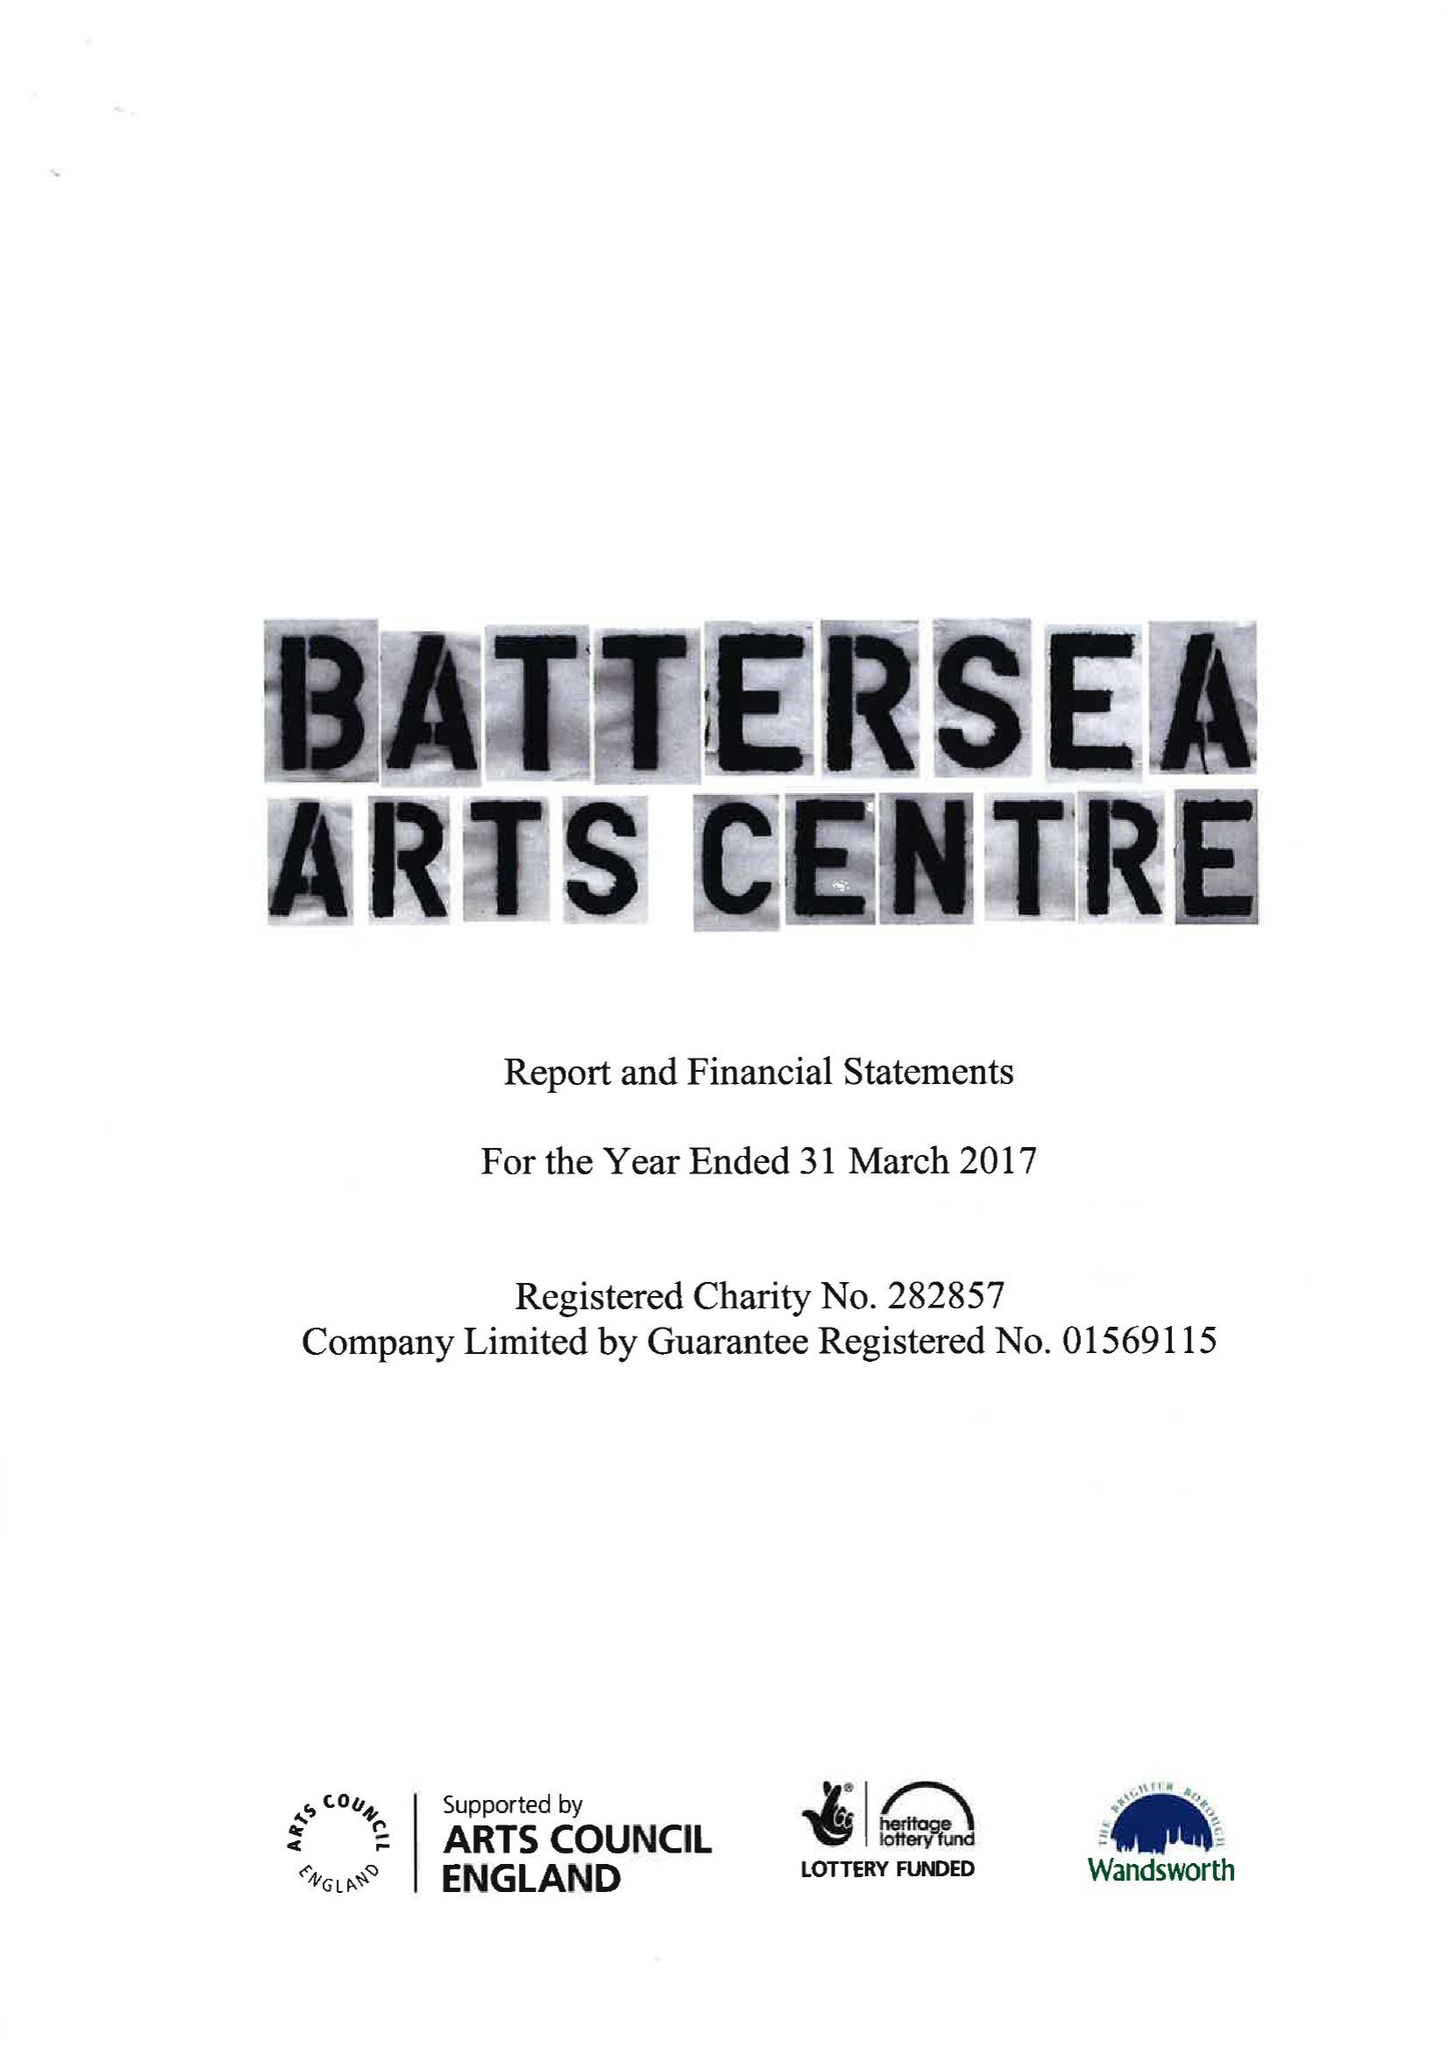What is the value for the address__postcode?
Answer the question using a single word or phrase. SW11 5TN 